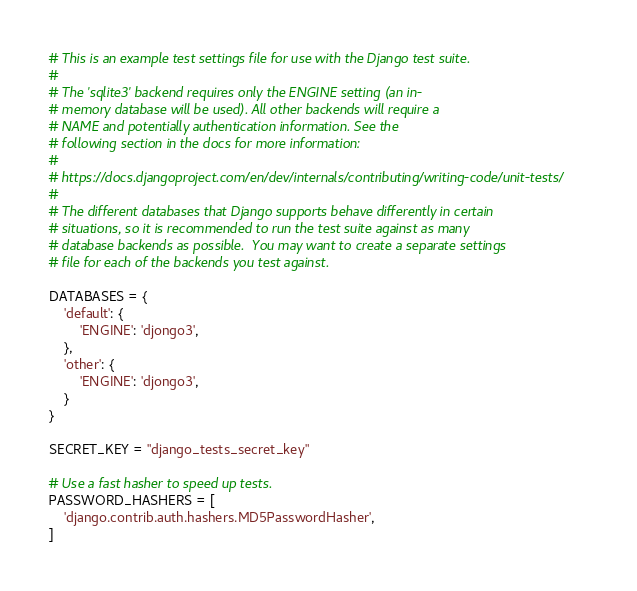<code> <loc_0><loc_0><loc_500><loc_500><_Python_># This is an example test settings file for use with the Django test suite.
#
# The 'sqlite3' backend requires only the ENGINE setting (an in-
# memory database will be used). All other backends will require a
# NAME and potentially authentication information. See the
# following section in the docs for more information:
#
# https://docs.djangoproject.com/en/dev/internals/contributing/writing-code/unit-tests/
#
# The different databases that Django supports behave differently in certain
# situations, so it is recommended to run the test suite against as many
# database backends as possible.  You may want to create a separate settings
# file for each of the backends you test against.

DATABASES = {
    'default': {
        'ENGINE': 'djongo3',
    },
    'other': {
        'ENGINE': 'djongo3',
    }
}

SECRET_KEY = "django_tests_secret_key"

# Use a fast hasher to speed up tests.
PASSWORD_HASHERS = [
    'django.contrib.auth.hashers.MD5PasswordHasher',
]
</code> 